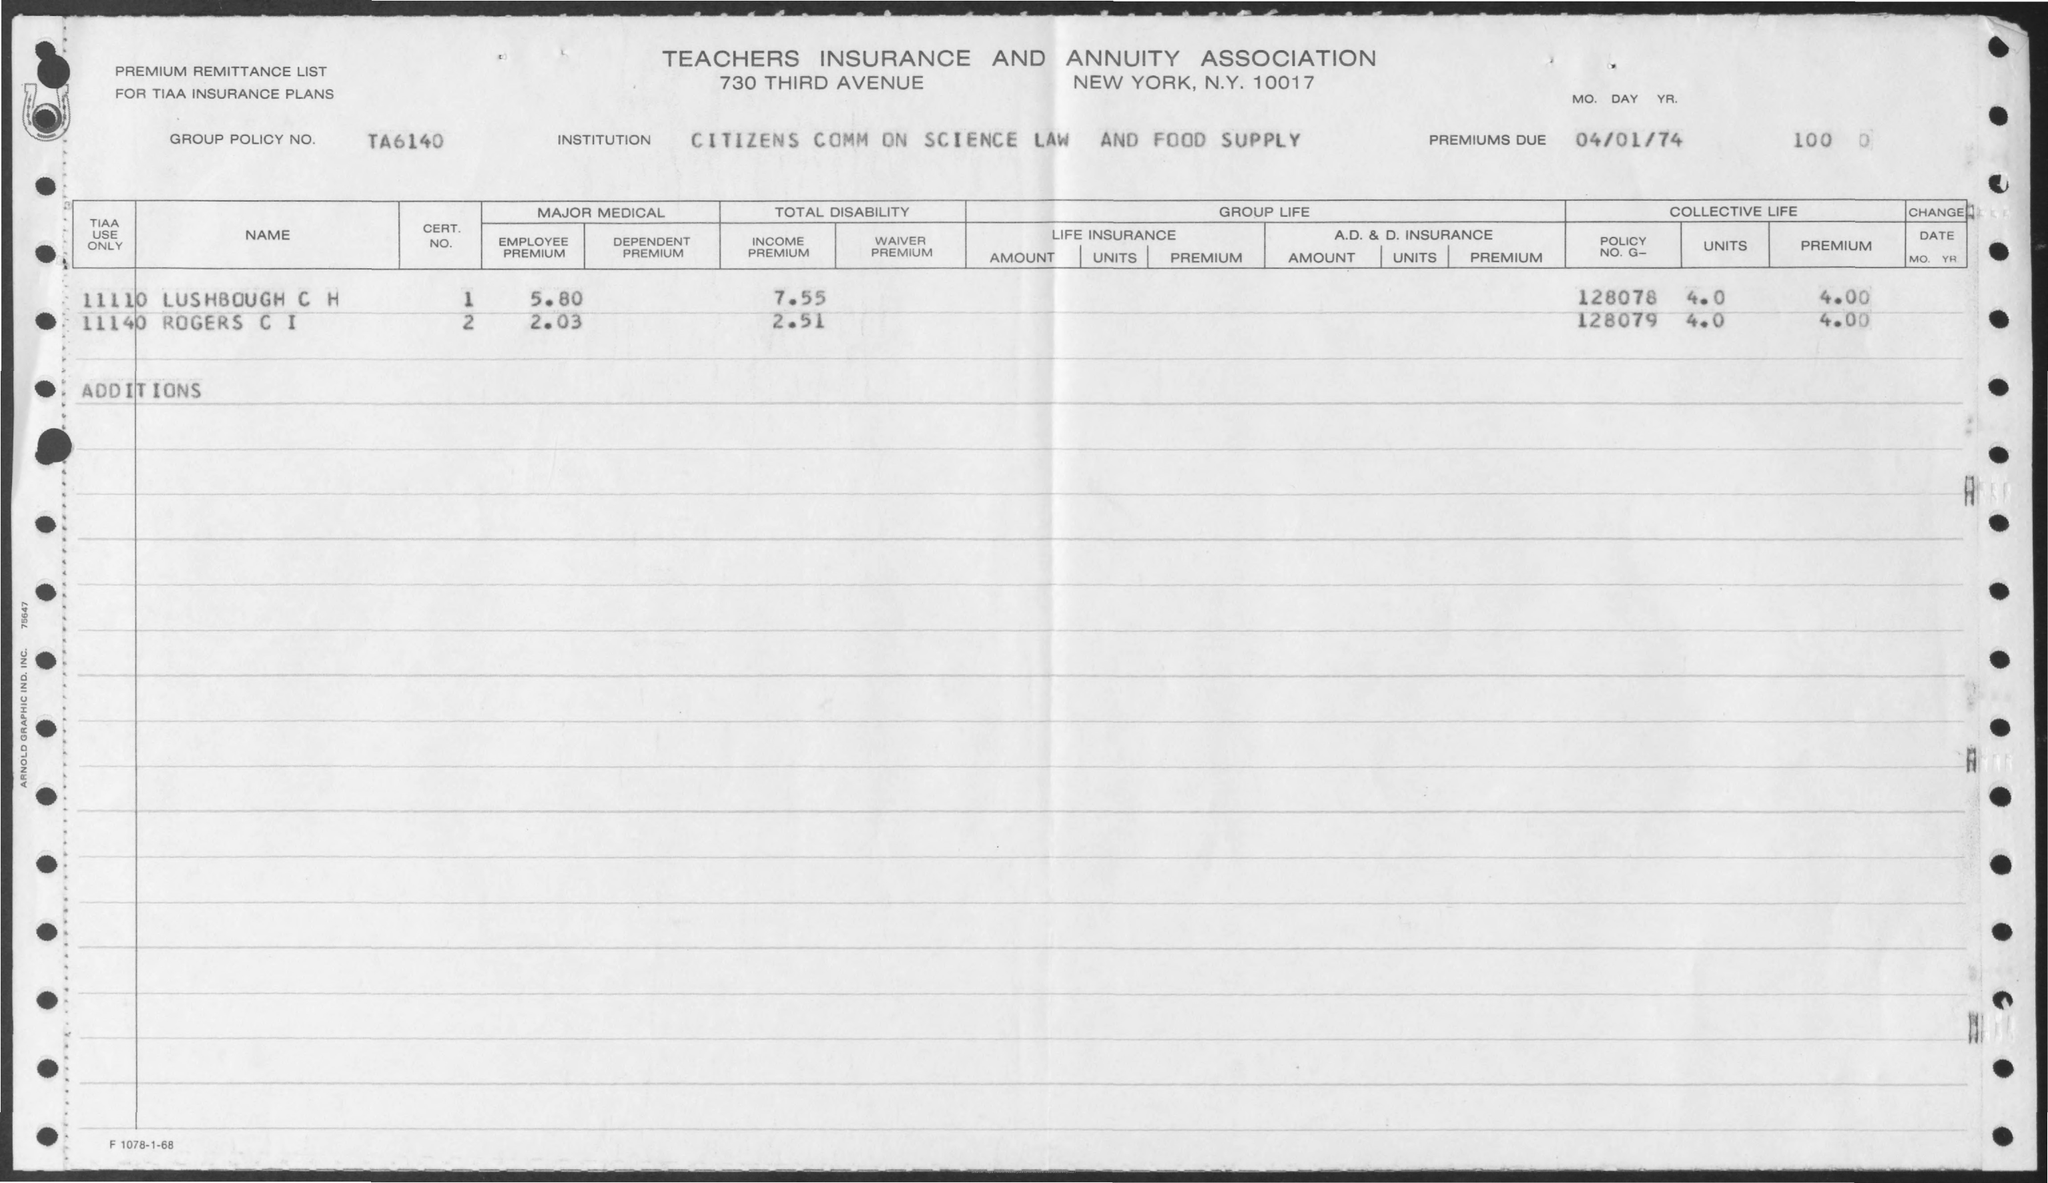Give some essential details in this illustration. The Teachers Insurance and Annuity Association is the name of the association. The group policy number mentioned on the given page is TA6140. The premium value for Lush Bough C I is 4.00, as provided on the page. The employee premium value for Rogers C I is 2.03. What is the policy number G for Lush Bough C H?" is a question asking for information about a specific policy. The policy number G refers to the unique identifier for the policy in question, while Lush Bough C H refers to the location or organization associated with the policy. The question is asking for the policy number G for a specific location or organization, such as "What is the policy number G for Lush Bough C H? 